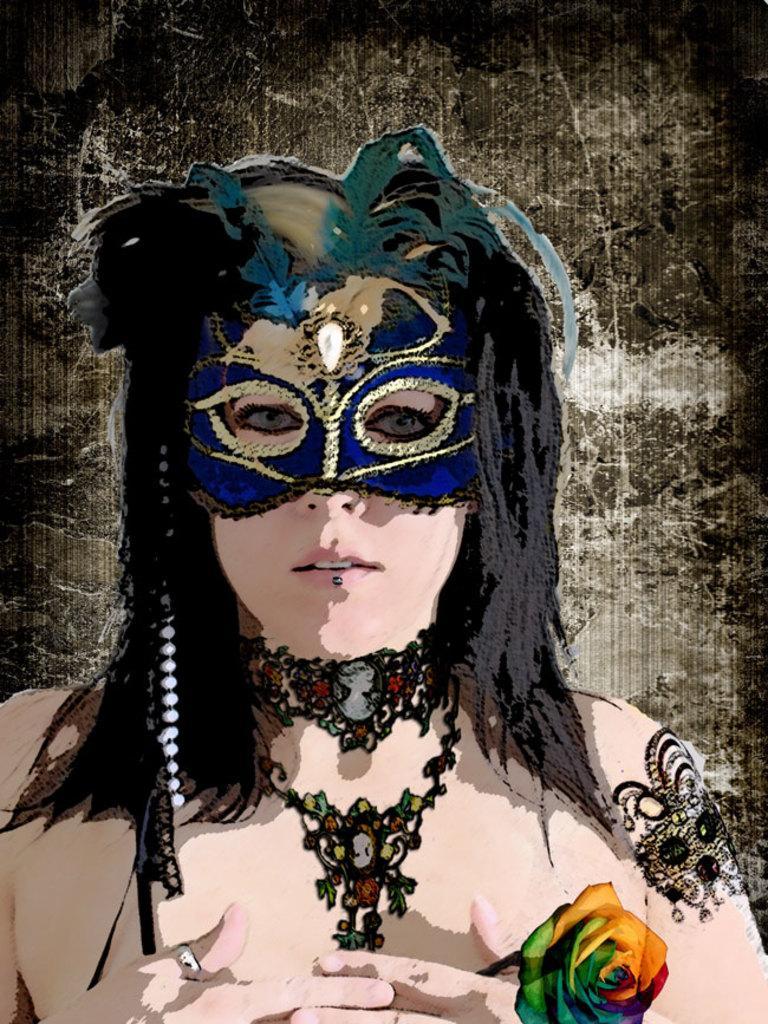Describe this image in one or two sentences. In this Image I can see painting of a woman. I can see she is wearing blue mask, necklace and she is holding a flower. 